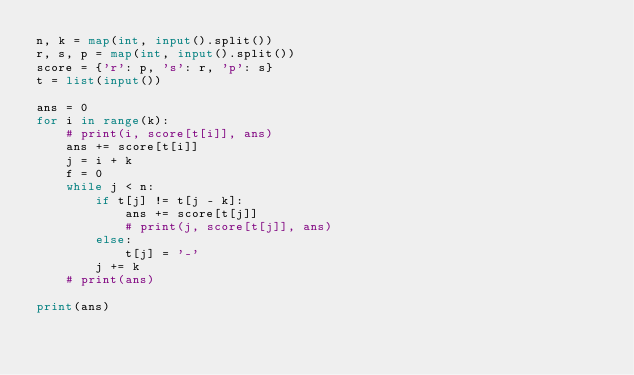Convert code to text. <code><loc_0><loc_0><loc_500><loc_500><_Python_>n, k = map(int, input().split())
r, s, p = map(int, input().split())
score = {'r': p, 's': r, 'p': s}
t = list(input())

ans = 0
for i in range(k):
    # print(i, score[t[i]], ans)
    ans += score[t[i]]
    j = i + k
    f = 0
    while j < n:
        if t[j] != t[j - k]:
            ans += score[t[j]]
            # print(j, score[t[j]], ans)
        else:
            t[j] = '-'
        j += k
    # print(ans)

print(ans)
</code> 